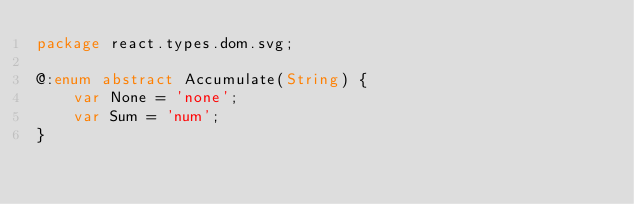Convert code to text. <code><loc_0><loc_0><loc_500><loc_500><_Haxe_>package react.types.dom.svg;

@:enum abstract Accumulate(String) {
	var None = 'none';
	var Sum = 'num';
}
</code> 